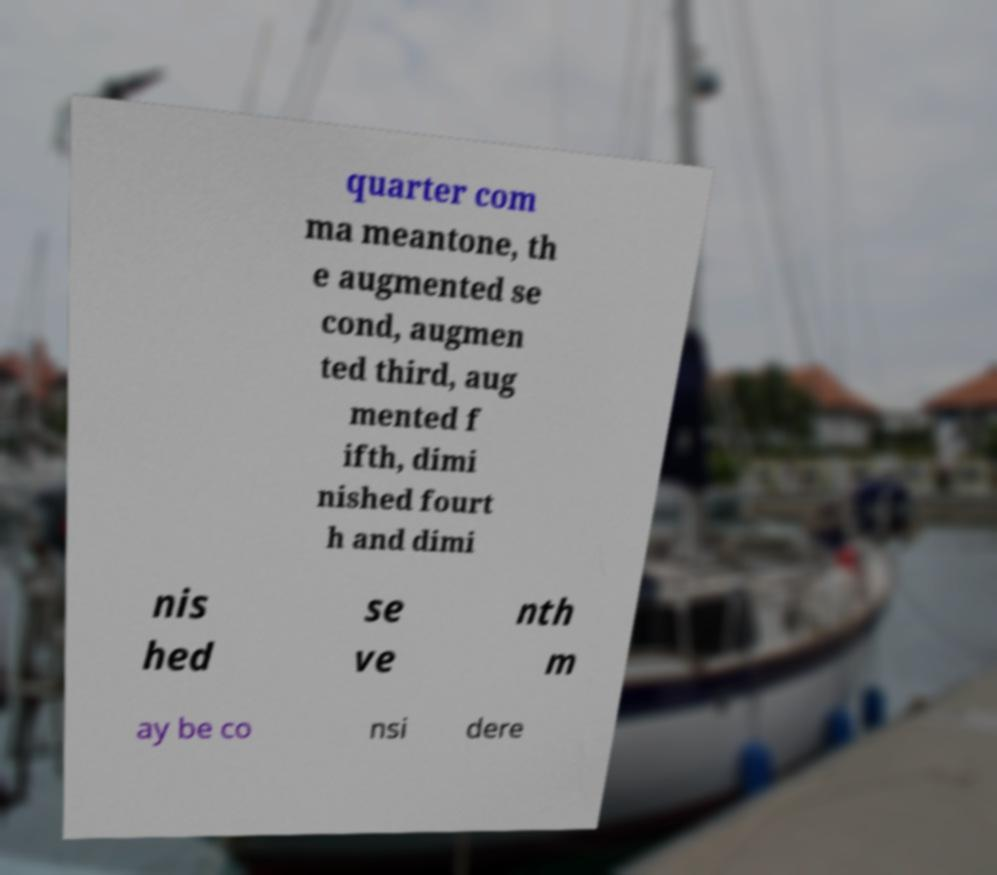Could you assist in decoding the text presented in this image and type it out clearly? quarter com ma meantone, th e augmented se cond, augmen ted third, aug mented f ifth, dimi nished fourt h and dimi nis hed se ve nth m ay be co nsi dere 